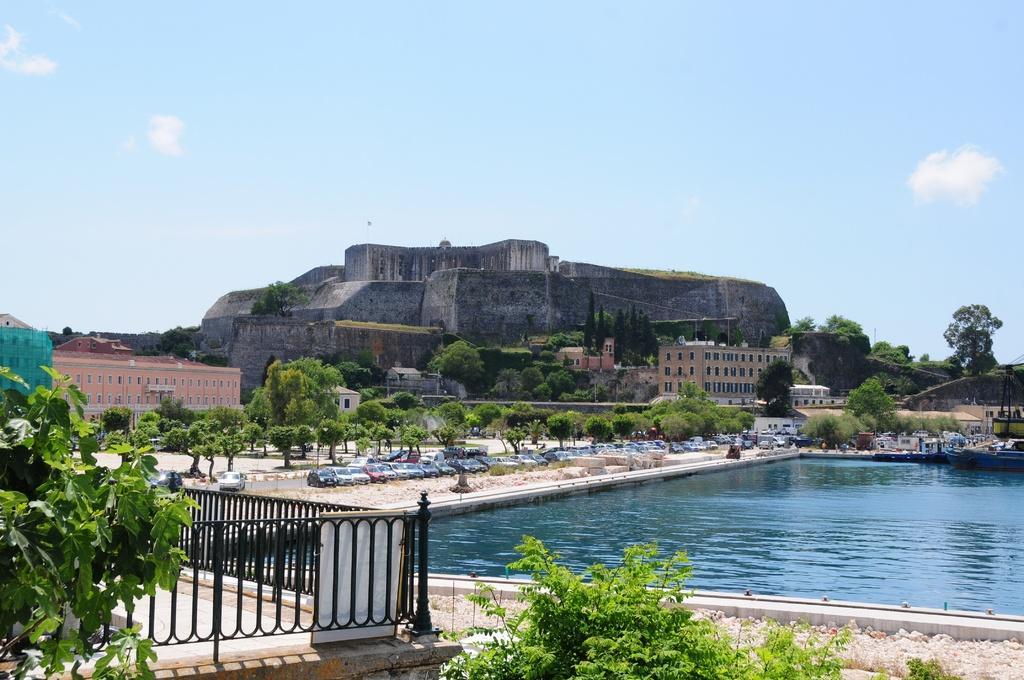Describe this image in one or two sentences. In this picture there is water in the right corner and there is fence and few plants in the left corner and there are trees,vehicles and buildings in the background. 